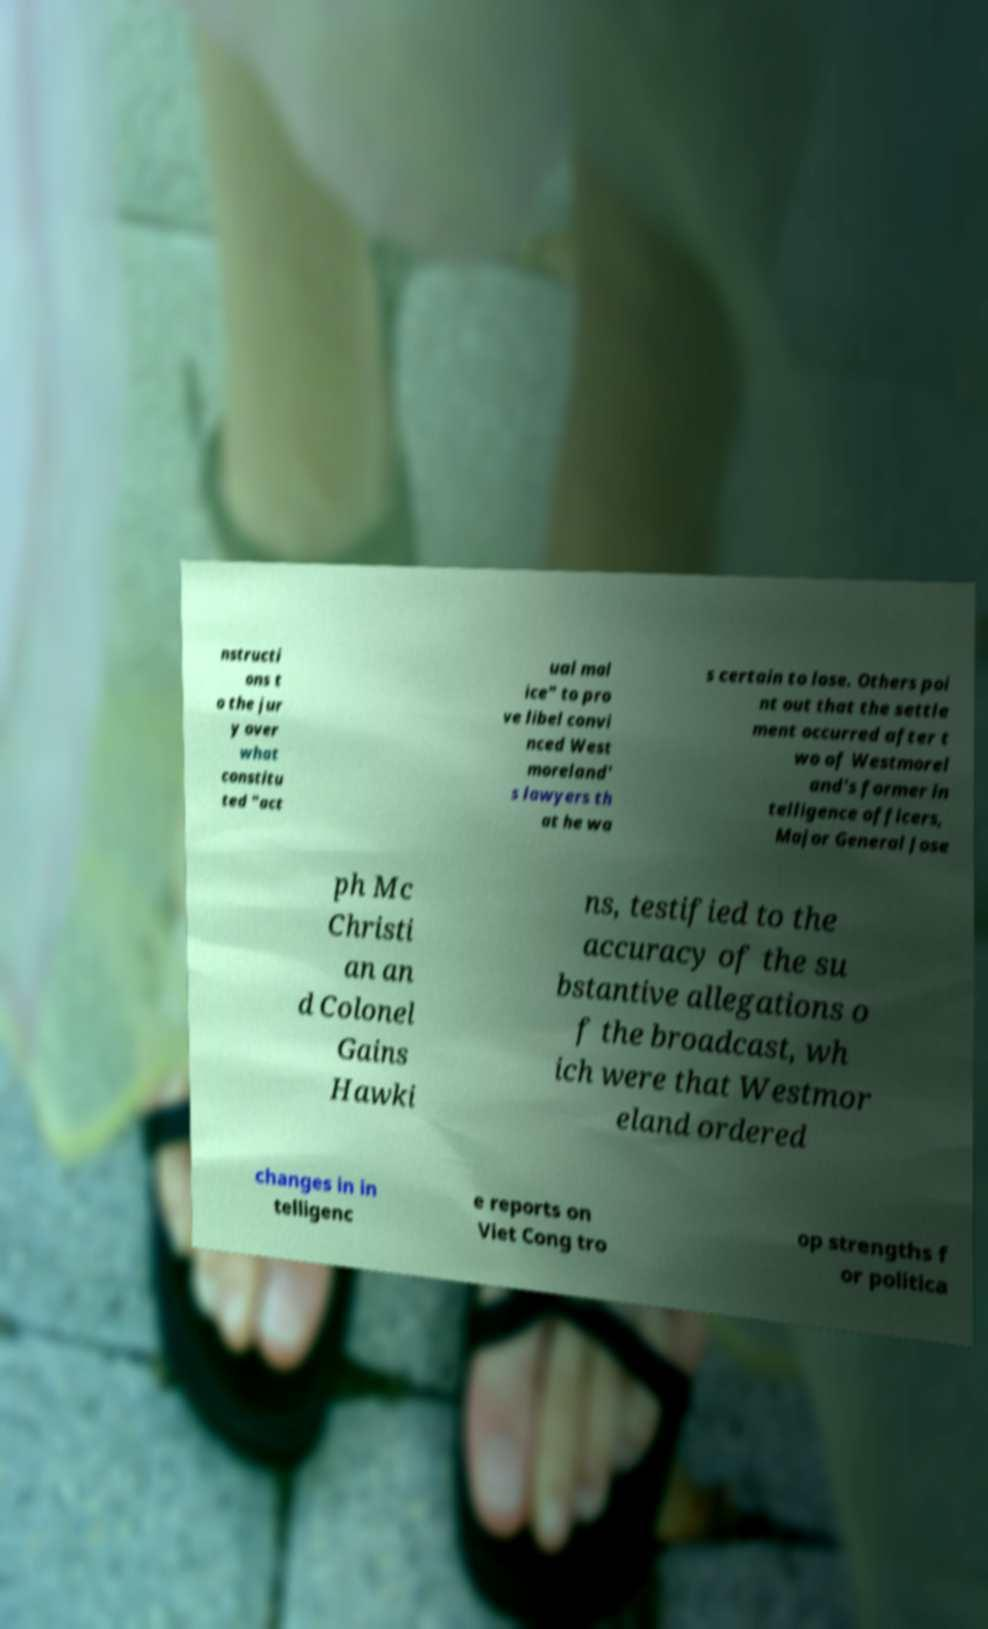I need the written content from this picture converted into text. Can you do that? nstructi ons t o the jur y over what constitu ted "act ual mal ice" to pro ve libel convi nced West moreland' s lawyers th at he wa s certain to lose. Others poi nt out that the settle ment occurred after t wo of Westmorel and's former in telligence officers, Major General Jose ph Mc Christi an an d Colonel Gains Hawki ns, testified to the accuracy of the su bstantive allegations o f the broadcast, wh ich were that Westmor eland ordered changes in in telligenc e reports on Viet Cong tro op strengths f or politica 